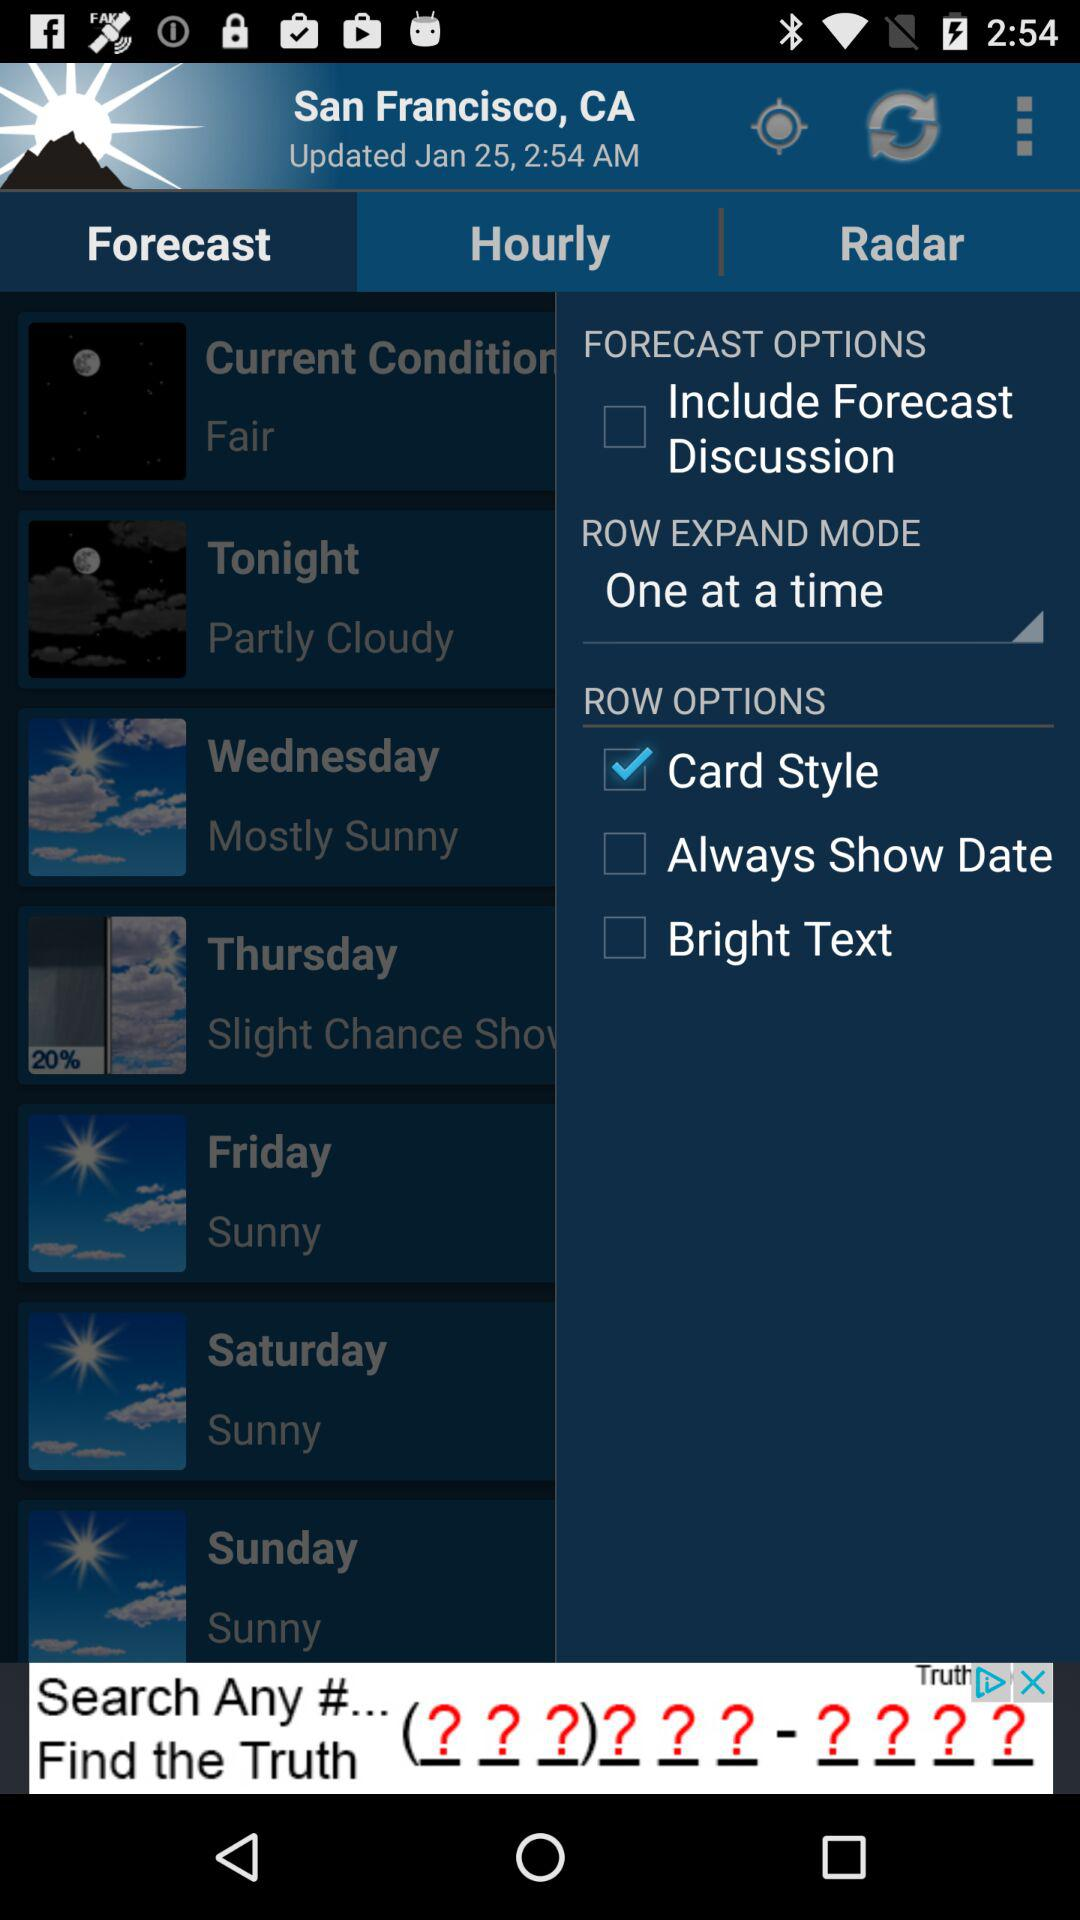What is the location? The location is San Francisco, CA. 